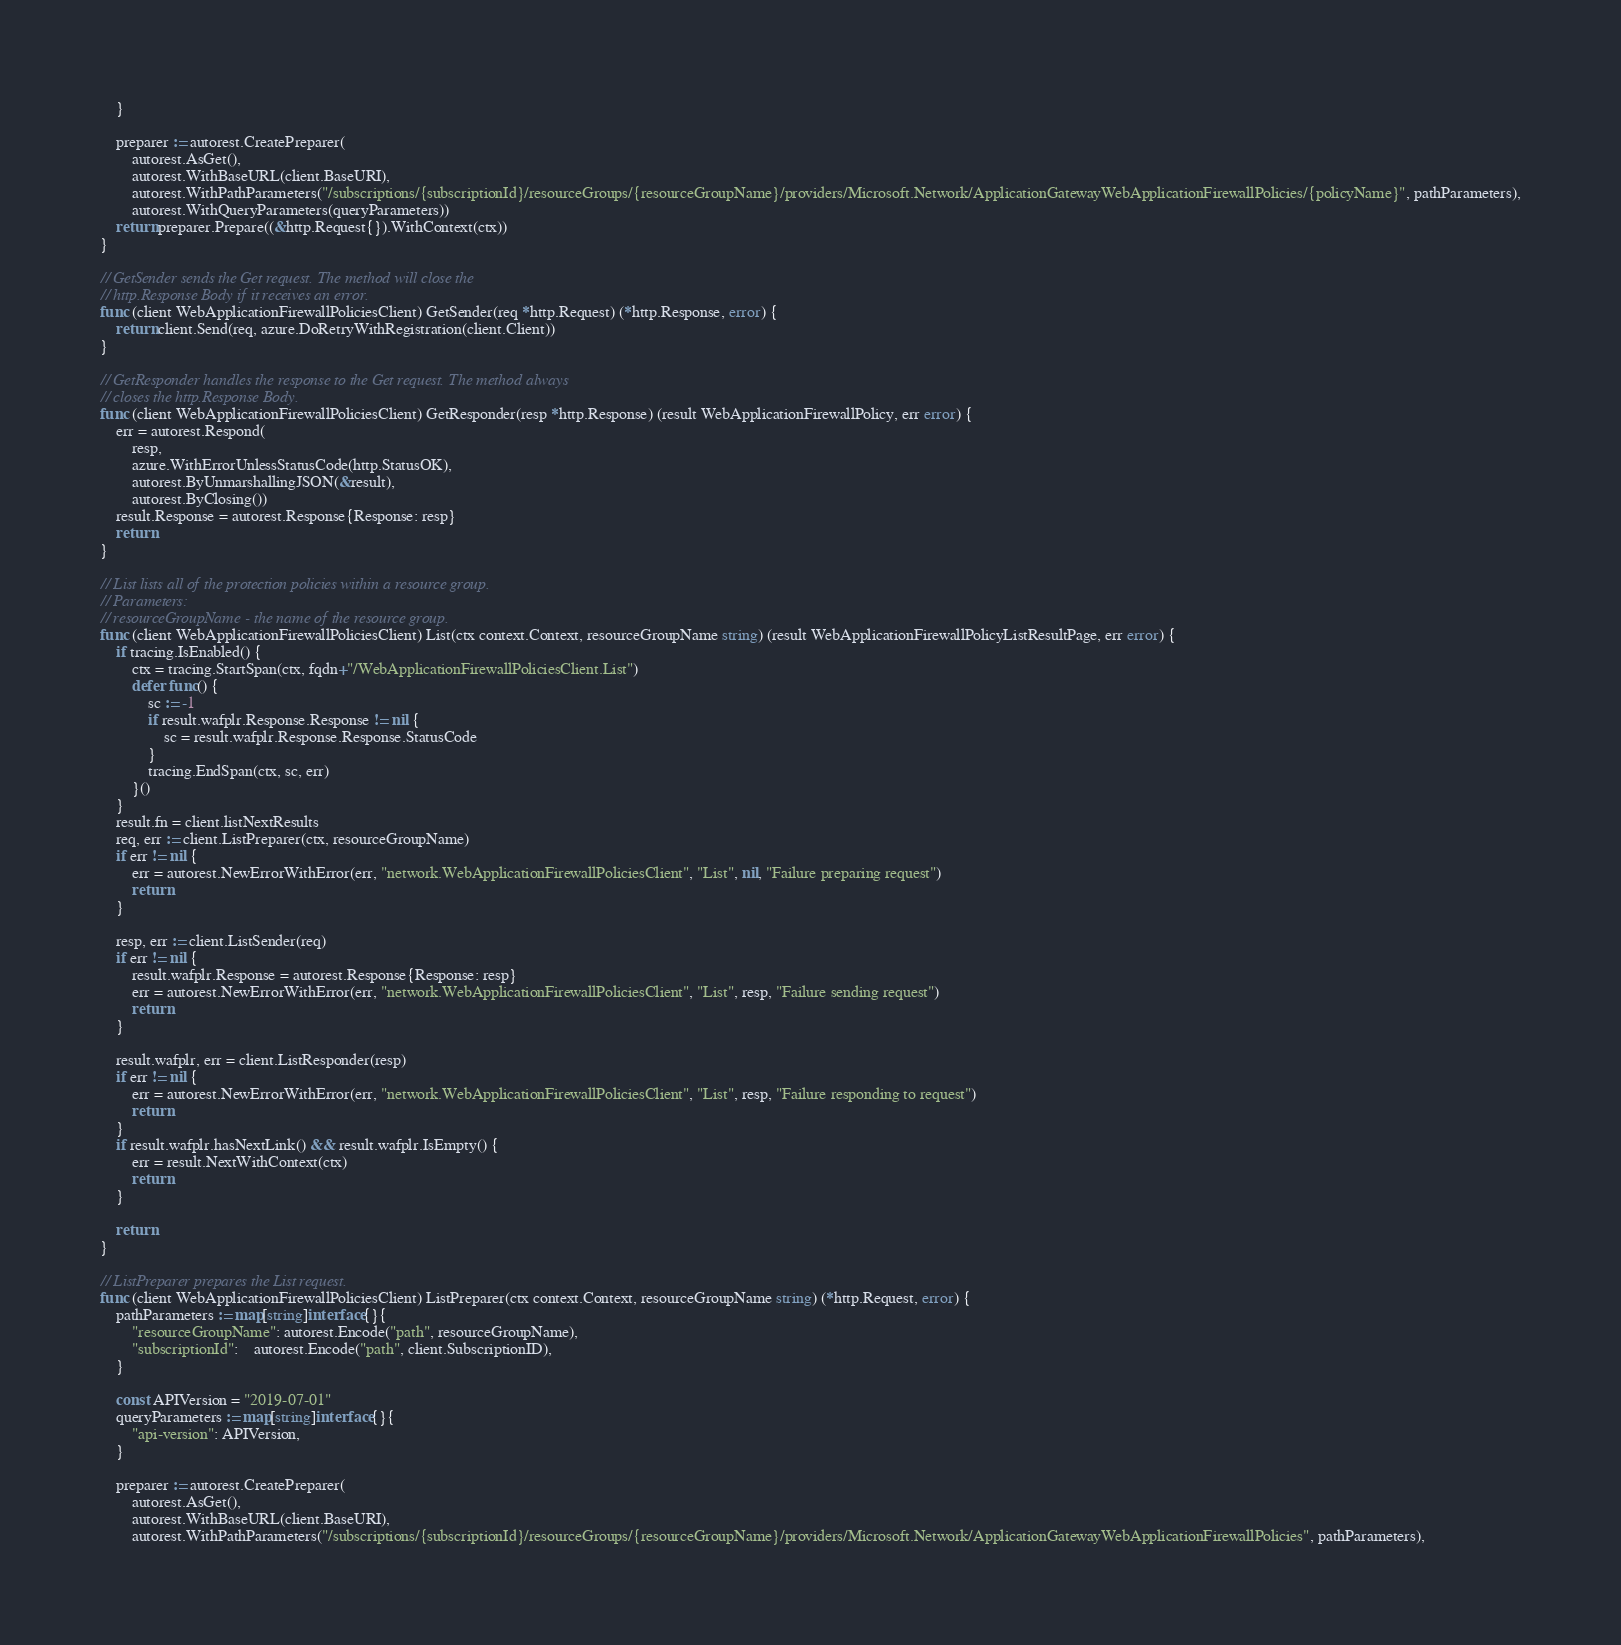<code> <loc_0><loc_0><loc_500><loc_500><_Go_>	}

	preparer := autorest.CreatePreparer(
		autorest.AsGet(),
		autorest.WithBaseURL(client.BaseURI),
		autorest.WithPathParameters("/subscriptions/{subscriptionId}/resourceGroups/{resourceGroupName}/providers/Microsoft.Network/ApplicationGatewayWebApplicationFirewallPolicies/{policyName}", pathParameters),
		autorest.WithQueryParameters(queryParameters))
	return preparer.Prepare((&http.Request{}).WithContext(ctx))
}

// GetSender sends the Get request. The method will close the
// http.Response Body if it receives an error.
func (client WebApplicationFirewallPoliciesClient) GetSender(req *http.Request) (*http.Response, error) {
	return client.Send(req, azure.DoRetryWithRegistration(client.Client))
}

// GetResponder handles the response to the Get request. The method always
// closes the http.Response Body.
func (client WebApplicationFirewallPoliciesClient) GetResponder(resp *http.Response) (result WebApplicationFirewallPolicy, err error) {
	err = autorest.Respond(
		resp,
		azure.WithErrorUnlessStatusCode(http.StatusOK),
		autorest.ByUnmarshallingJSON(&result),
		autorest.ByClosing())
	result.Response = autorest.Response{Response: resp}
	return
}

// List lists all of the protection policies within a resource group.
// Parameters:
// resourceGroupName - the name of the resource group.
func (client WebApplicationFirewallPoliciesClient) List(ctx context.Context, resourceGroupName string) (result WebApplicationFirewallPolicyListResultPage, err error) {
	if tracing.IsEnabled() {
		ctx = tracing.StartSpan(ctx, fqdn+"/WebApplicationFirewallPoliciesClient.List")
		defer func() {
			sc := -1
			if result.wafplr.Response.Response != nil {
				sc = result.wafplr.Response.Response.StatusCode
			}
			tracing.EndSpan(ctx, sc, err)
		}()
	}
	result.fn = client.listNextResults
	req, err := client.ListPreparer(ctx, resourceGroupName)
	if err != nil {
		err = autorest.NewErrorWithError(err, "network.WebApplicationFirewallPoliciesClient", "List", nil, "Failure preparing request")
		return
	}

	resp, err := client.ListSender(req)
	if err != nil {
		result.wafplr.Response = autorest.Response{Response: resp}
		err = autorest.NewErrorWithError(err, "network.WebApplicationFirewallPoliciesClient", "List", resp, "Failure sending request")
		return
	}

	result.wafplr, err = client.ListResponder(resp)
	if err != nil {
		err = autorest.NewErrorWithError(err, "network.WebApplicationFirewallPoliciesClient", "List", resp, "Failure responding to request")
		return
	}
	if result.wafplr.hasNextLink() && result.wafplr.IsEmpty() {
		err = result.NextWithContext(ctx)
		return
	}

	return
}

// ListPreparer prepares the List request.
func (client WebApplicationFirewallPoliciesClient) ListPreparer(ctx context.Context, resourceGroupName string) (*http.Request, error) {
	pathParameters := map[string]interface{}{
		"resourceGroupName": autorest.Encode("path", resourceGroupName),
		"subscriptionId":    autorest.Encode("path", client.SubscriptionID),
	}

	const APIVersion = "2019-07-01"
	queryParameters := map[string]interface{}{
		"api-version": APIVersion,
	}

	preparer := autorest.CreatePreparer(
		autorest.AsGet(),
		autorest.WithBaseURL(client.BaseURI),
		autorest.WithPathParameters("/subscriptions/{subscriptionId}/resourceGroups/{resourceGroupName}/providers/Microsoft.Network/ApplicationGatewayWebApplicationFirewallPolicies", pathParameters),</code> 